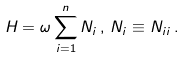Convert formula to latex. <formula><loc_0><loc_0><loc_500><loc_500>H = \omega \sum _ { i = 1 } ^ { n } N _ { i } \, , \, N _ { i } \equiv N _ { i i } \, .</formula> 